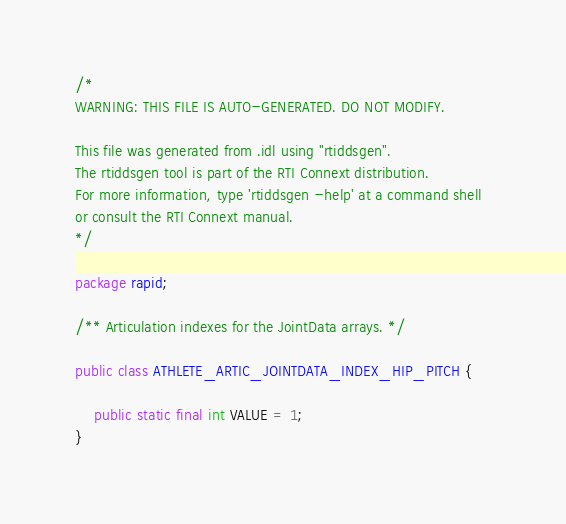Convert code to text. <code><loc_0><loc_0><loc_500><loc_500><_Java_>

/*
WARNING: THIS FILE IS AUTO-GENERATED. DO NOT MODIFY.

This file was generated from .idl using "rtiddsgen".
The rtiddsgen tool is part of the RTI Connext distribution.
For more information, type 'rtiddsgen -help' at a command shell
or consult the RTI Connext manual.
*/

package rapid;

/** Articulation indexes for the JointData arrays. */

public class ATHLETE_ARTIC_JOINTDATA_INDEX_HIP_PITCH {    

    public static final int VALUE = 1;
}
</code> 